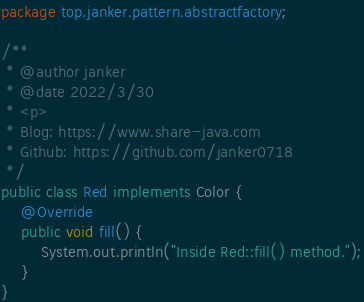Convert code to text. <code><loc_0><loc_0><loc_500><loc_500><_Java_>package top.janker.pattern.abstractfactory;

/**
 * @author janker
 * @date 2022/3/30
 * <p>
 * Blog: https://www.share-java.com
 * Github: https://github.com/janker0718
 */
public class Red implements Color {
    @Override
    public void fill() {
        System.out.println("Inside Red::fill() method.");
    }
}
</code> 